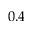<formula> <loc_0><loc_0><loc_500><loc_500>0 . 4</formula> 